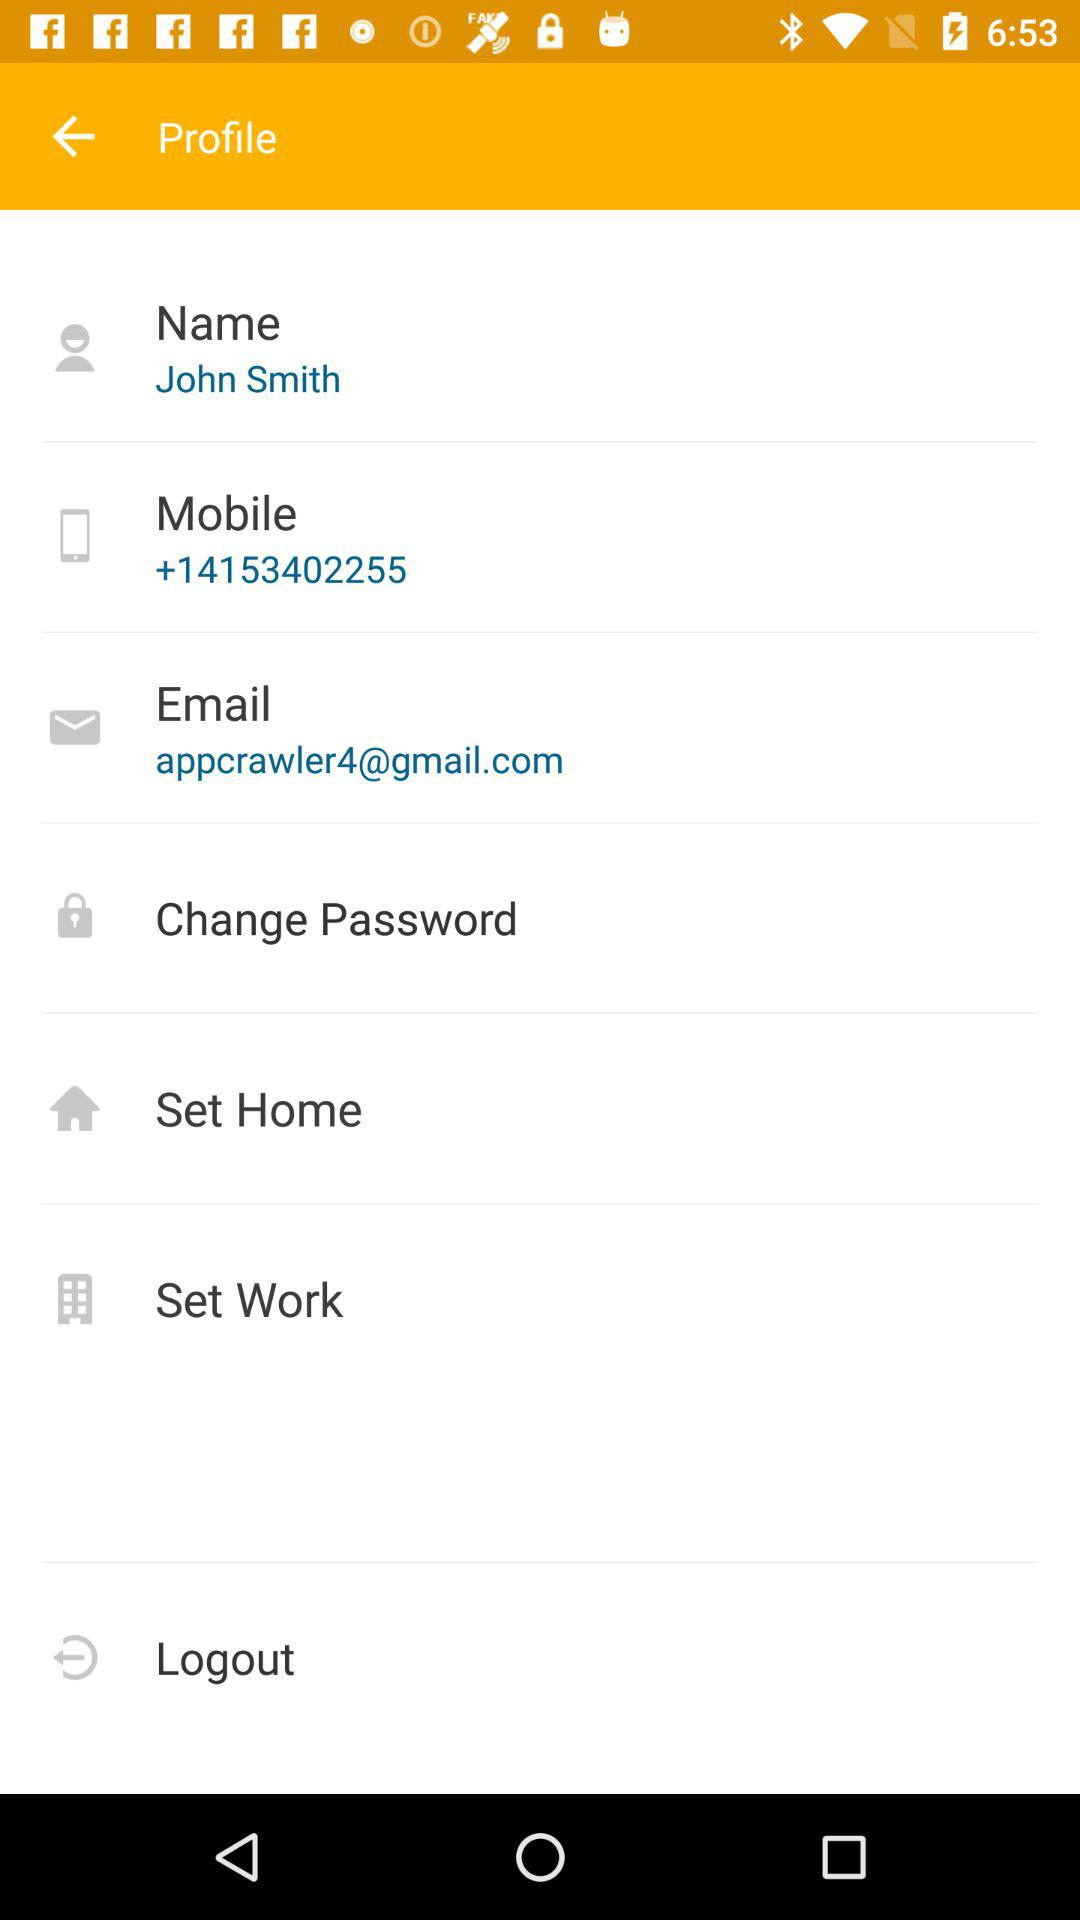What is the email address? The email address is appcrawler4@gmail.com. 